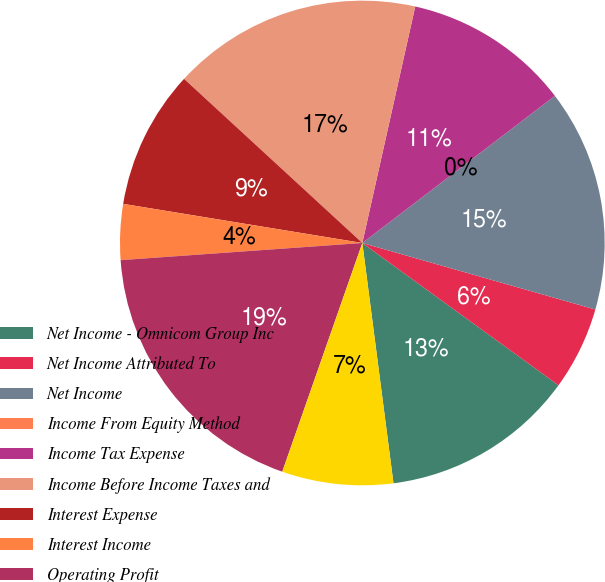<chart> <loc_0><loc_0><loc_500><loc_500><pie_chart><fcel>Net Income - Omnicom Group Inc<fcel>Net Income Attributed To<fcel>Net Income<fcel>Income From Equity Method<fcel>Income Tax Expense<fcel>Income Before Income Taxes and<fcel>Interest Expense<fcel>Interest Income<fcel>Operating Profit<fcel>Add back Amortization of<nl><fcel>12.96%<fcel>5.56%<fcel>14.81%<fcel>0.0%<fcel>11.11%<fcel>16.66%<fcel>9.26%<fcel>3.71%<fcel>18.51%<fcel>7.41%<nl></chart> 